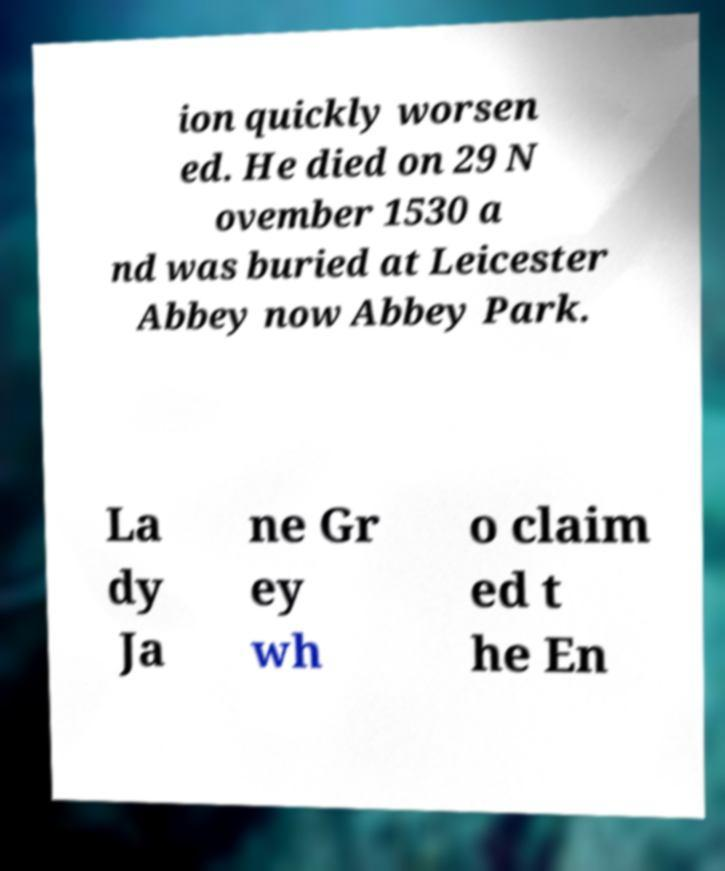What messages or text are displayed in this image? I need them in a readable, typed format. ion quickly worsen ed. He died on 29 N ovember 1530 a nd was buried at Leicester Abbey now Abbey Park. La dy Ja ne Gr ey wh o claim ed t he En 